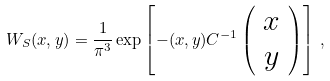<formula> <loc_0><loc_0><loc_500><loc_500>W _ { S } ( { x } , { y } ) = \frac { 1 } { \pi ^ { 3 } } \exp \left [ - ( { x } , { y } ) { C } ^ { - 1 } \left ( \begin{array} { c } { x } \\ { y } \end{array} \right ) \right ] \, ,</formula> 